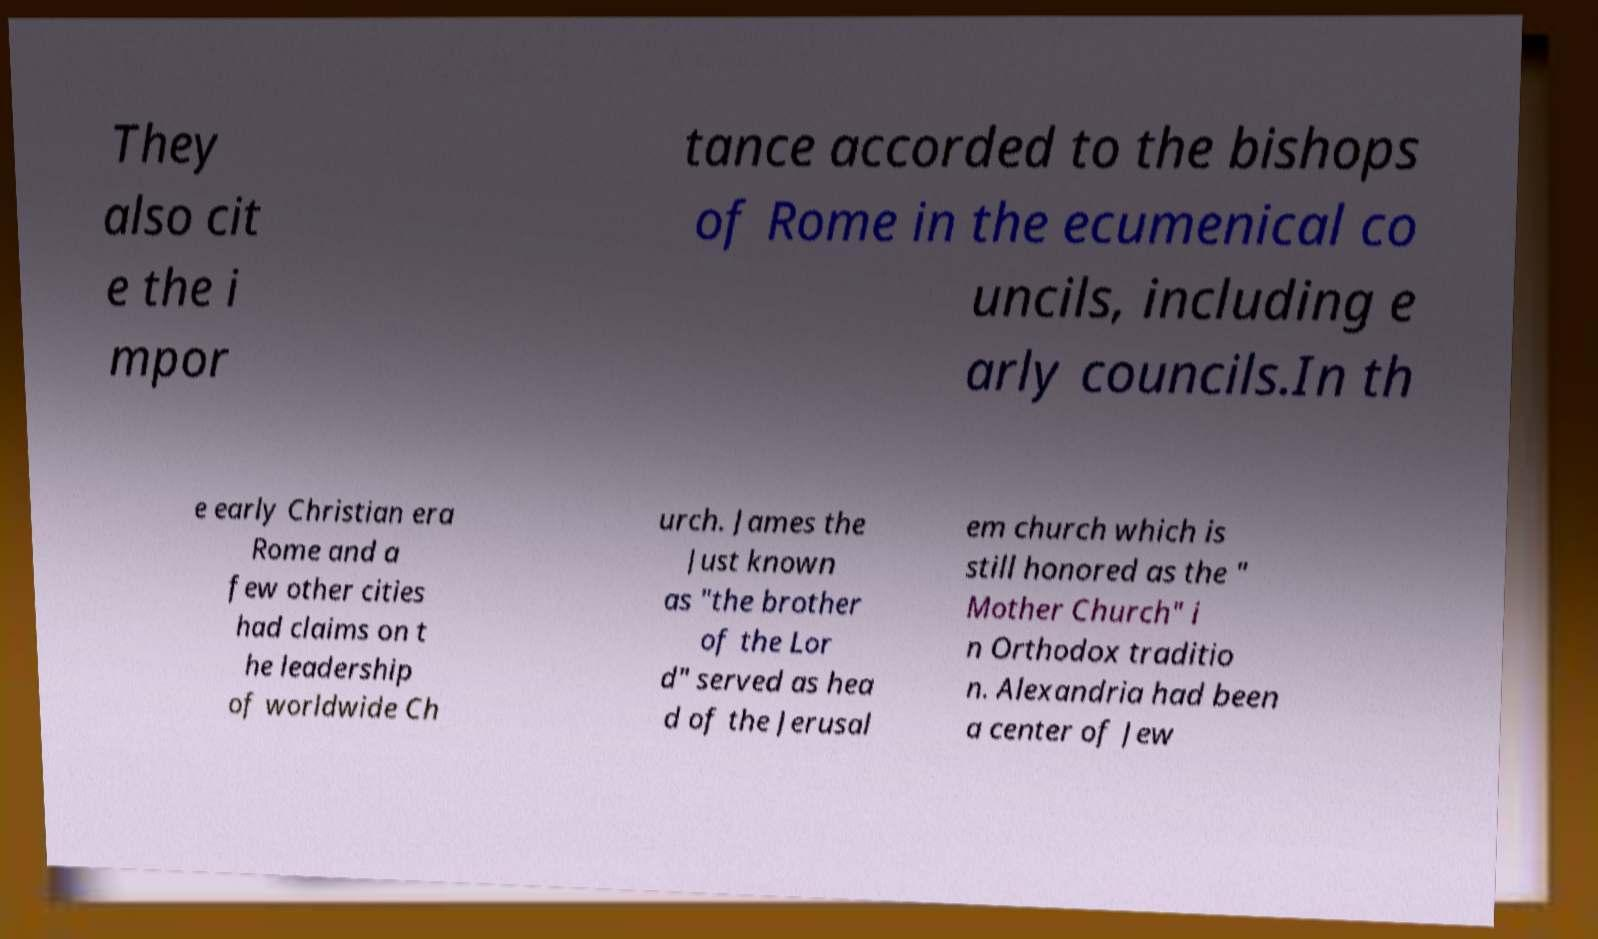What messages or text are displayed in this image? I need them in a readable, typed format. They also cit e the i mpor tance accorded to the bishops of Rome in the ecumenical co uncils, including e arly councils.In th e early Christian era Rome and a few other cities had claims on t he leadership of worldwide Ch urch. James the Just known as "the brother of the Lor d" served as hea d of the Jerusal em church which is still honored as the " Mother Church" i n Orthodox traditio n. Alexandria had been a center of Jew 